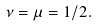Convert formula to latex. <formula><loc_0><loc_0><loc_500><loc_500>\nu = \mu = 1 / 2 .</formula> 